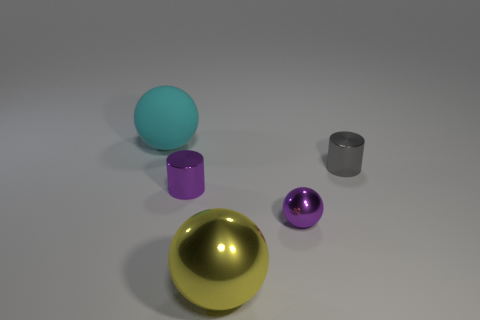There is a small purple thing that is on the right side of the tiny purple cylinder; what material is it?
Your response must be concise. Metal. There is a thing that is behind the small metallic cylinder that is behind the cylinder that is in front of the tiny gray shiny cylinder; what color is it?
Offer a very short reply. Cyan. What color is the metal sphere that is the same size as the cyan rubber sphere?
Your response must be concise. Yellow. What number of rubber things are either small green things or yellow balls?
Your response must be concise. 0. There is another big thing that is made of the same material as the gray object; what is its color?
Provide a succinct answer. Yellow. What is the material of the cylinder right of the small shiny thing to the left of the purple sphere?
Your response must be concise. Metal. What number of things are either yellow spheres left of the purple ball or small purple metallic things right of the large yellow metallic thing?
Provide a succinct answer. 2. There is a cylinder behind the shiny object that is to the left of the large thing that is in front of the rubber sphere; what is its size?
Keep it short and to the point. Small. Are there an equal number of small gray things to the left of the yellow shiny sphere and big red metal cylinders?
Make the answer very short. Yes. There is a big matte object; is its shape the same as the metallic object that is in front of the purple metal ball?
Provide a short and direct response. Yes. 